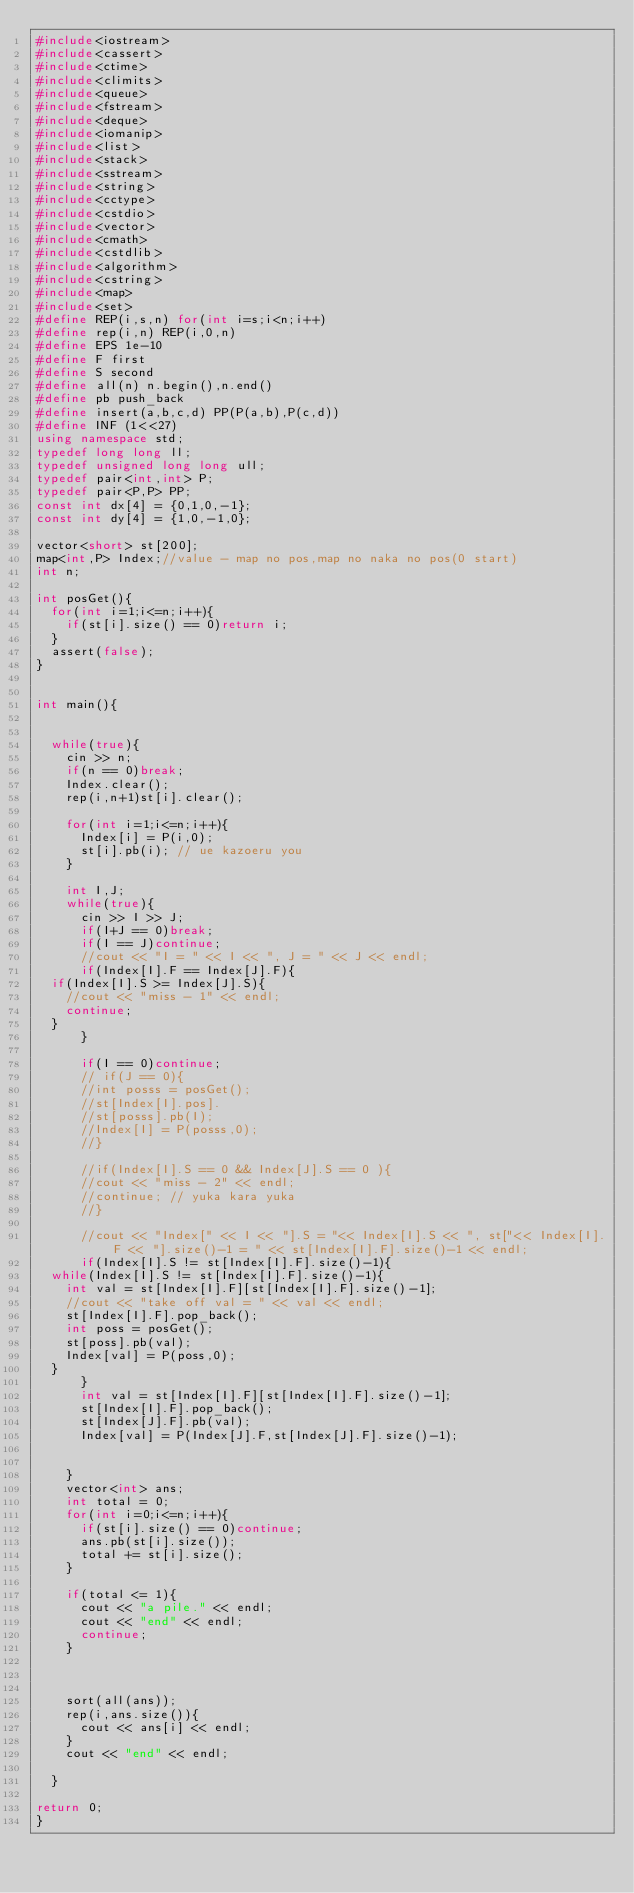<code> <loc_0><loc_0><loc_500><loc_500><_C++_>#include<iostream>
#include<cassert>
#include<ctime>
#include<climits>
#include<queue>
#include<fstream>
#include<deque>
#include<iomanip>
#include<list>
#include<stack>
#include<sstream>
#include<string>
#include<cctype>
#include<cstdio>
#include<vector>
#include<cmath>
#include<cstdlib>
#include<algorithm>
#include<cstring>
#include<map>
#include<set>
#define REP(i,s,n) for(int i=s;i<n;i++)
#define rep(i,n) REP(i,0,n)
#define EPS 1e-10
#define F first
#define S second
#define all(n) n.begin(),n.end()
#define pb push_back
#define insert(a,b,c,d) PP(P(a,b),P(c,d))
#define INF (1<<27)
using namespace std;
typedef long long ll;
typedef unsigned long long ull;
typedef pair<int,int> P;
typedef pair<P,P> PP;
const int dx[4] = {0,1,0,-1};
const int dy[4] = {1,0,-1,0};

vector<short> st[200];
map<int,P> Index;//value - map no pos,map no naka no pos(0 start)
int n;

int posGet(){
  for(int i=1;i<=n;i++){
    if(st[i].size() == 0)return i;
  }
  assert(false);
}


int main(){
 

  while(true){
    cin >> n;
    if(n == 0)break;
    Index.clear();   
    rep(i,n+1)st[i].clear();

    for(int i=1;i<=n;i++){
      Index[i] = P(i,0);
      st[i].pb(i); // ue kazoeru you 
    }
   
    int I,J;
    while(true){
      cin >> I >> J;
      if(I+J == 0)break;
      if(I == J)continue;
      //cout << "I = " << I << ", J = " << J << endl;
      if(Index[I].F == Index[J].F){
	if(Index[I].S >= Index[J].S){
	  //cout << "miss - 1" << endl;
	  continue;
	}
      }

      if(I == 0)continue;
      // if(J == 0){
      //int posss = posGet();
      //st[Index[I].pos].
      //st[posss].pb(I);
      //Index[I] = P(posss,0);
      //}

      //if(Index[I].S == 0 && Index[J].S == 0 ){
      //cout << "miss - 2" << endl; 
      //continue; // yuka kara yuka
      //}

      //cout << "Index[" << I << "].S = "<< Index[I].S << ", st["<< Index[I].F << "].size()-1 = " << st[Index[I].F].size()-1 << endl;
      if(Index[I].S != st[Index[I].F].size()-1){
	while(Index[I].S != st[Index[I].F].size()-1){
	  int val = st[Index[I].F][st[Index[I].F].size()-1];
	  //cout << "take off val = " << val << endl;
	  st[Index[I].F].pop_back();
	  int poss = posGet();
	  st[poss].pb(val);
	  Index[val] = P(poss,0); 
	}
      }
      int val = st[Index[I].F][st[Index[I].F].size()-1];
      st[Index[I].F].pop_back();
      st[Index[J].F].pb(val);
      Index[val] = P(Index[J].F,st[Index[J].F].size()-1);


    }
    vector<int> ans;
    int total = 0;
    for(int i=0;i<=n;i++){
      if(st[i].size() == 0)continue;
      ans.pb(st[i].size());
      total += st[i].size();
    }

    if(total <= 1){
      cout << "a pile." << endl;
      cout << "end" << endl;
      continue;
    }

    

    sort(all(ans));
    rep(i,ans.size()){
      cout << ans[i] << endl;
    }
    cout << "end" << endl;

  }

return 0;
}</code> 